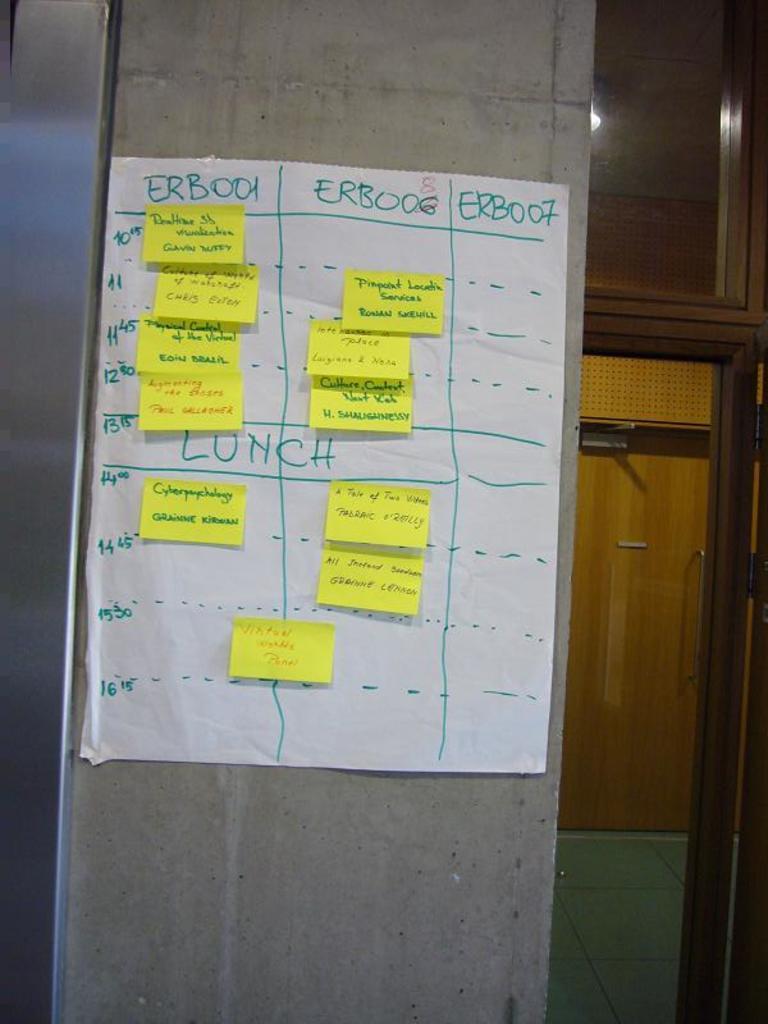Could you give a brief overview of what you see in this image? We can see a paper attached on a wall,on this paper we can see papers. In the background we can see the door and floor. 